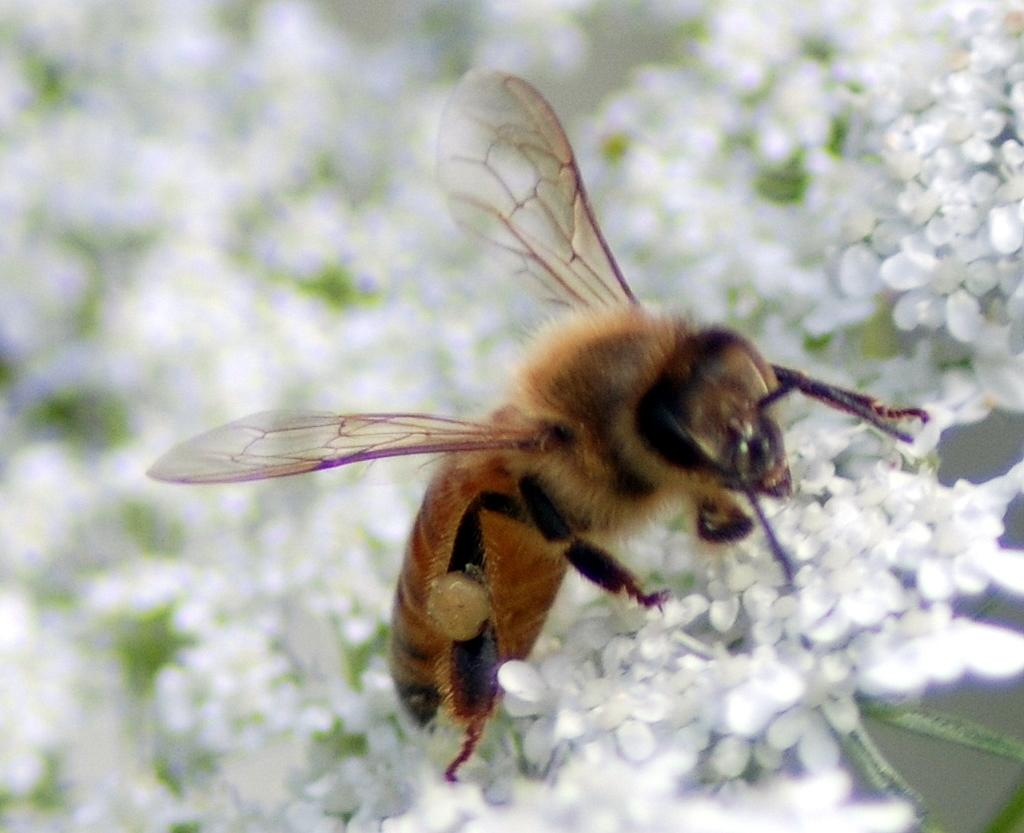What type of creature is present in the image? There is an insect in the image. Where is the insect located in the image? The insect is on some flowers. What type of mint can be seen growing near the insect in the image? There is no mint plant present in the image. Is there a volcano visible in the background of the image? There is no volcano present in the image. Can you see a ticket on the flowers where the insect is located? There is no ticket present in the image. 